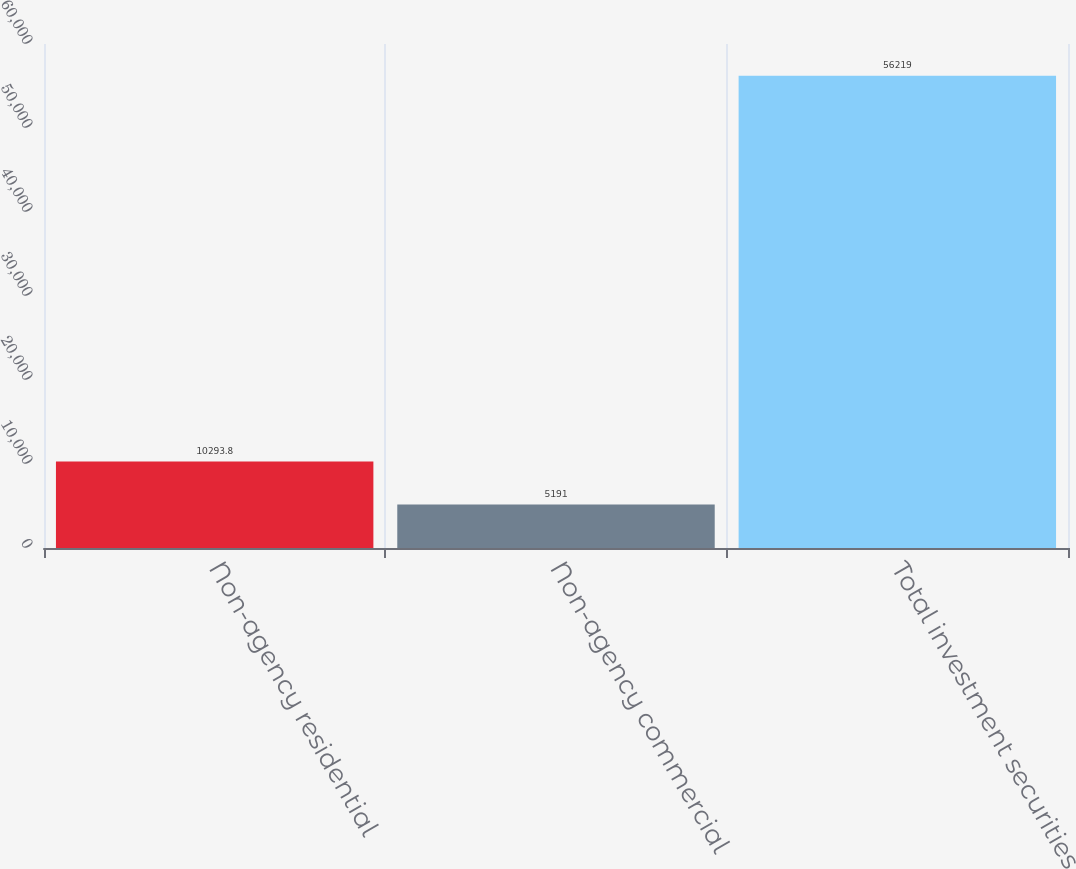Convert chart. <chart><loc_0><loc_0><loc_500><loc_500><bar_chart><fcel>Non-agency residential<fcel>Non-agency commercial<fcel>Total investment securities<nl><fcel>10293.8<fcel>5191<fcel>56219<nl></chart> 